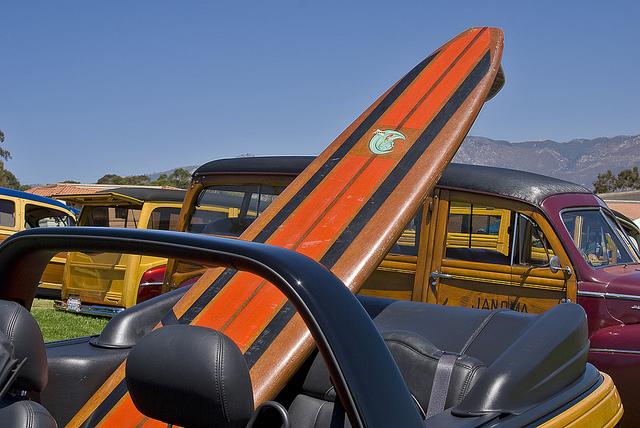Are those Woodys is the background?
Be succinct. Yes. What is in the backseat?
Quick response, please. Surfboard. What kind of vehicles are in this photo?
Keep it brief. Cars. Is the picture well focused?
Short answer required. Yes. What is the car filled with?
Quick response, please. Surfboard. 